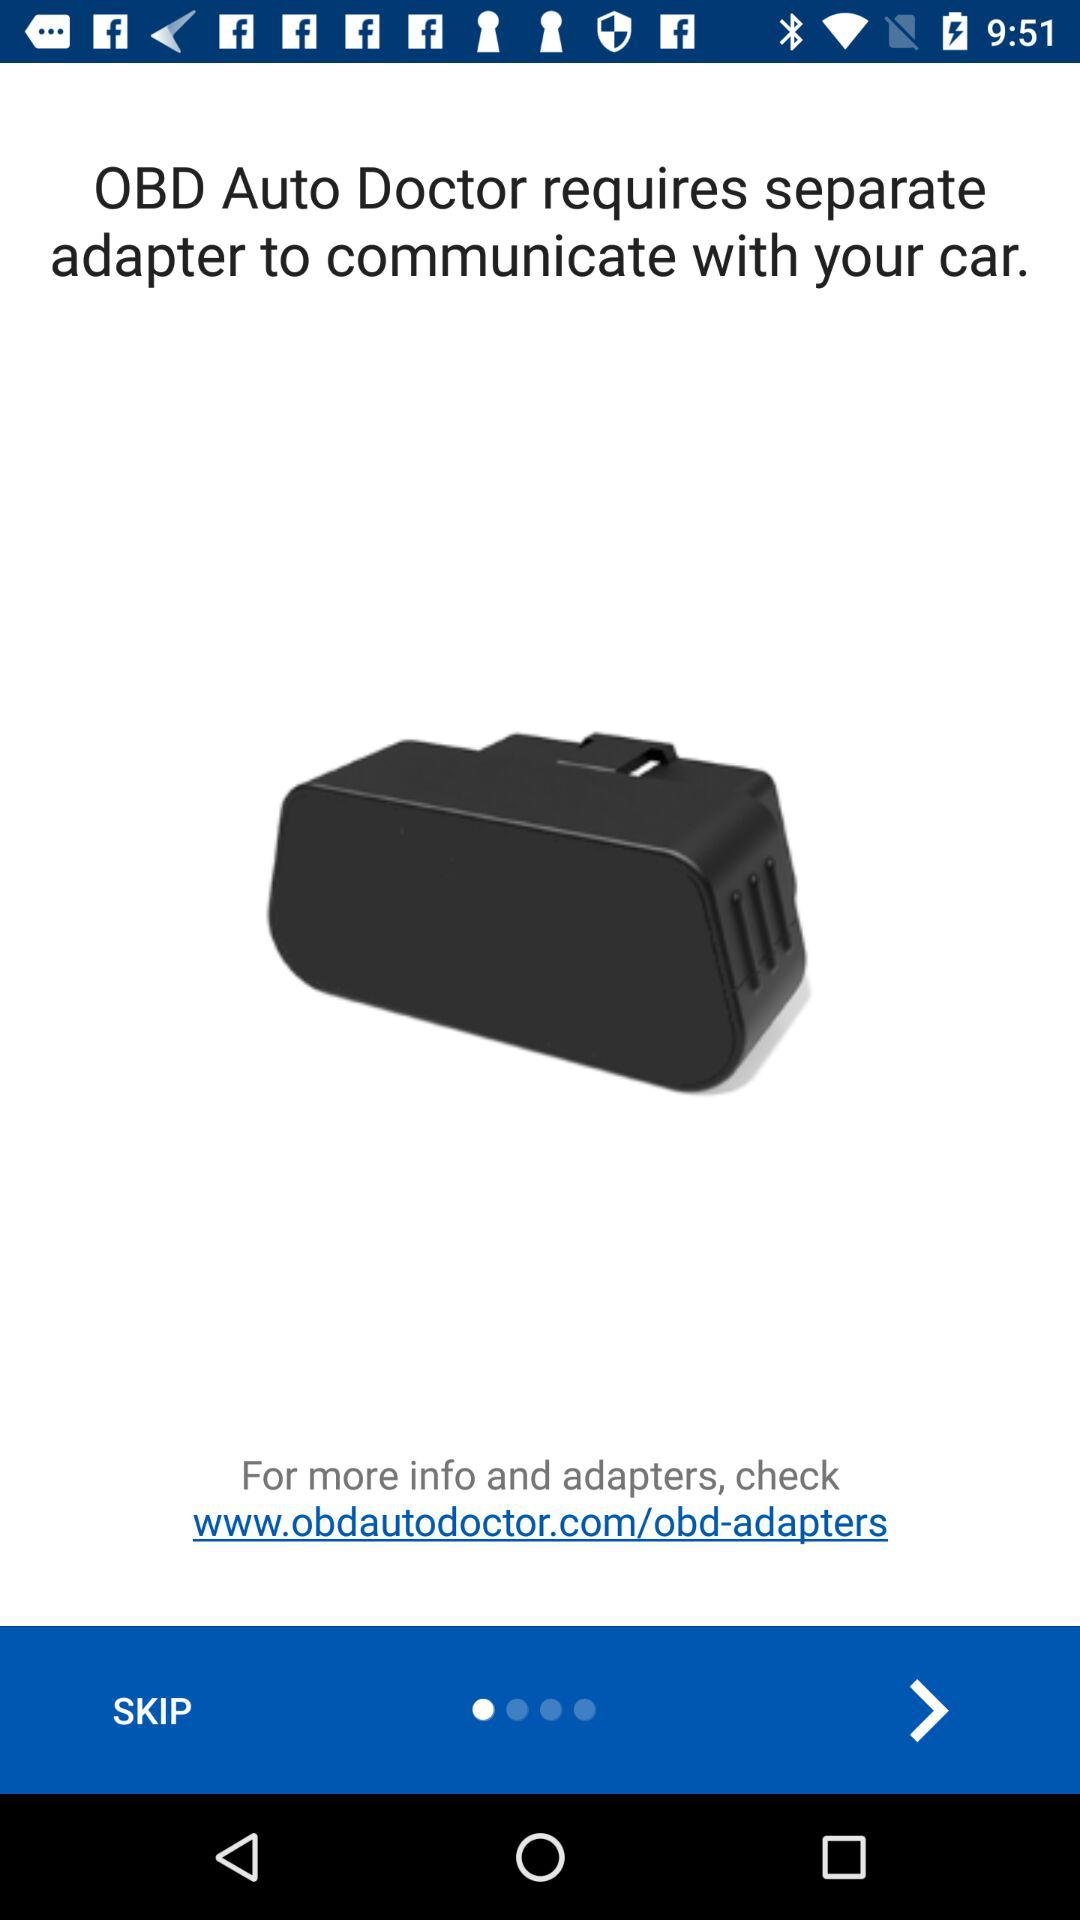What is the device name? The device name is "OBD Auto Doctor". 